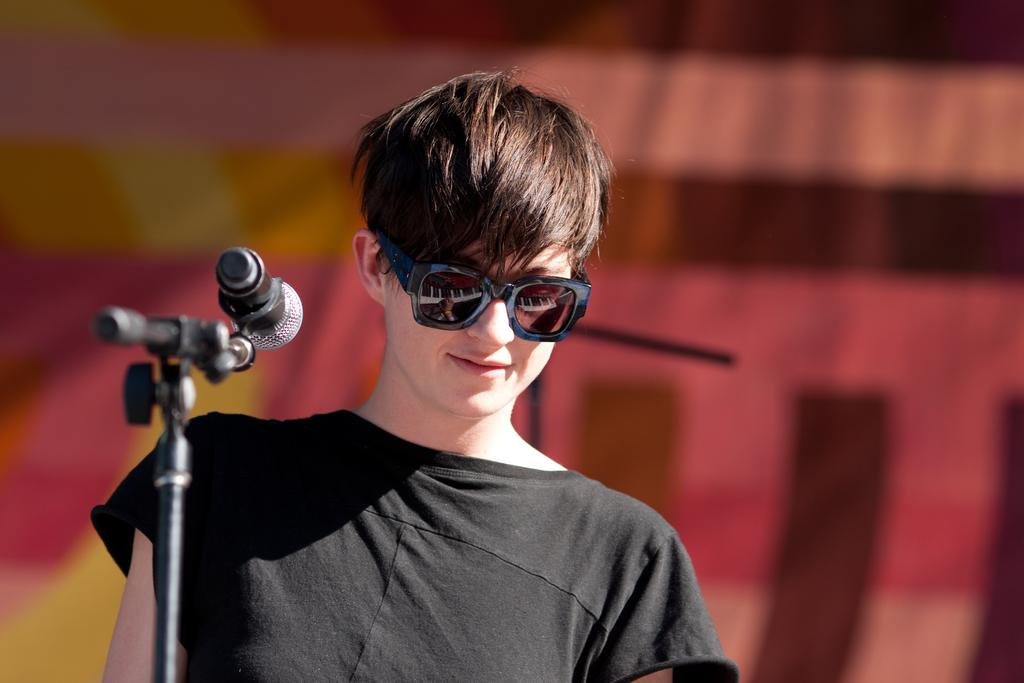Who is the main subject in the image? There is a woman in the image. What is the woman wearing on her eyes? The woman is wearing goggles on her eyes. What can be seen on the left side of the image? There is a microphone on a stand on the left side of the image. How would you describe the background of the image? The background of the image is blurred. Can you identify any objects in the background? Yes, there is an object visible in the background. What type of lead is the beggar holding in the image? There is no beggar or lead present in the image. Where is the library located in the image? There is no library present in the image. 